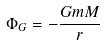Convert formula to latex. <formula><loc_0><loc_0><loc_500><loc_500>\Phi _ { G } = - \frac { G m M } { r }</formula> 